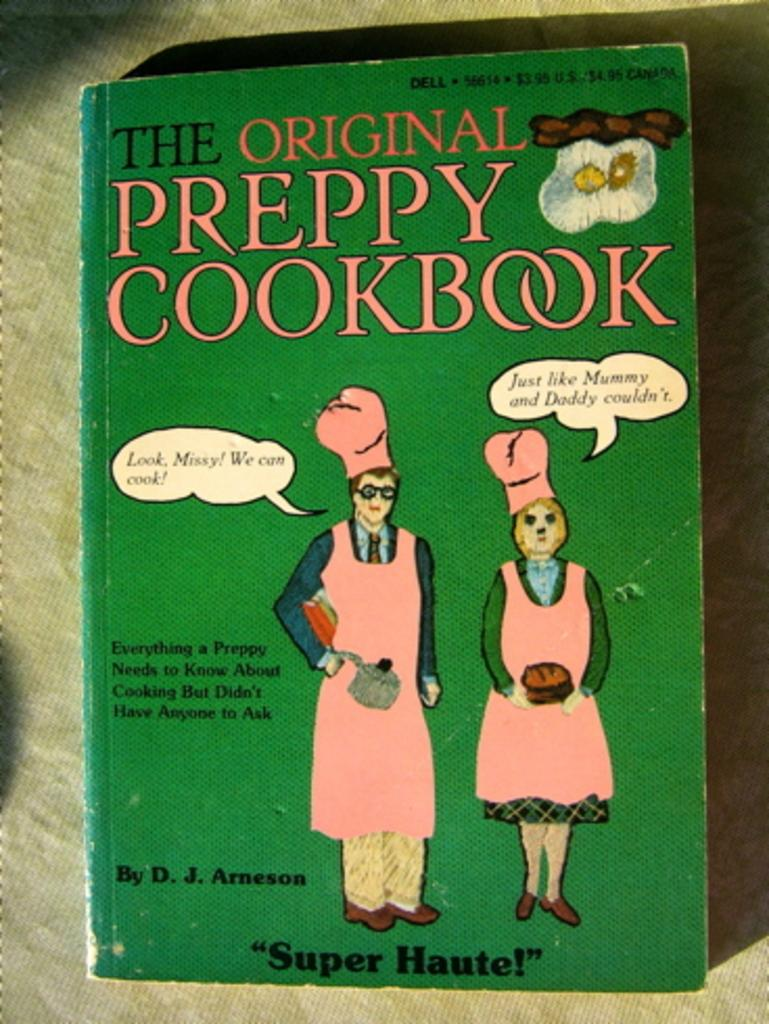What is the title of the book in the image? The book in the image is titled "The Original Preppy Cookbook." What type of content might be found in the book? The book contains images of two persons, which suggests it may include recipes or cooking-related information. What type of camera is used to capture images of the cookbook in space? There is no camera or space imagery present in the image; it only features a book with the title "The Original Preppy Cookbook." 